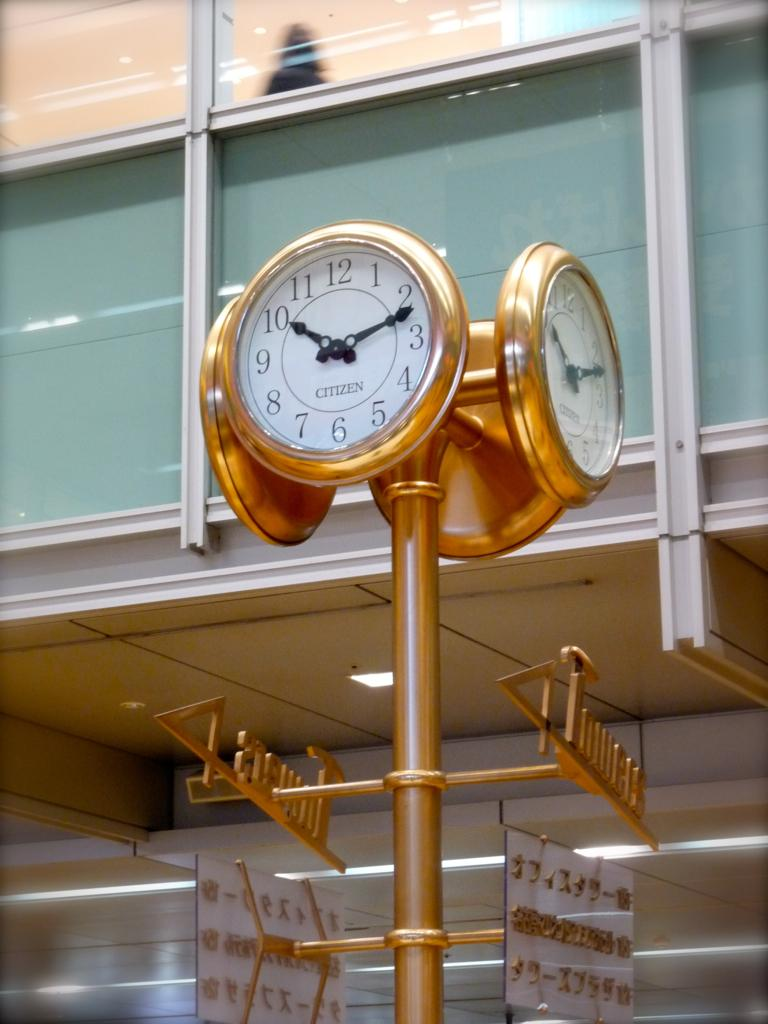Provide a one-sentence caption for the provided image. A clock is adorned with the brand-name Citizen. 